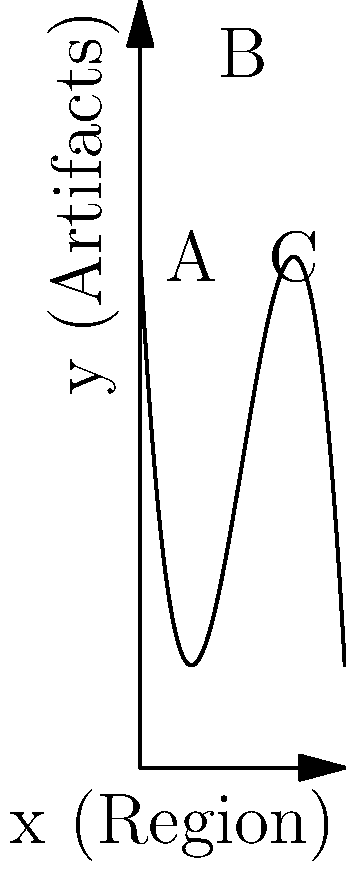The polynomial function $f(x) = -0.5x^3 + 6x^2 - 18x + 20$ models the distribution of traditional North Korean artifacts across different regions, where $x$ represents the region number and $f(x)$ represents the number of artifacts found. Based on the graph, in which region is the peak number of artifacts found, and how many artifacts are there at this peak? To find the peak number of artifacts and its corresponding region, we need to follow these steps:

1. Observe the graph: The curve reaches its highest point at point B.

2. Find the x-coordinate of point B: This represents the region number where the peak occurs. From the graph, we can see that point B is located at $x = 4$.

3. Calculate the y-coordinate of point B: This represents the number of artifacts at the peak. We need to evaluate $f(4)$:

   $f(4) = -0.5(4)^3 + 6(4)^2 - 18(4) + 20$
   $= -0.5(64) + 6(16) - 72 + 20$
   $= -32 + 96 - 72 + 20$
   $= 12$

4. Verify with the graph: The calculated y-value (12) doesn't match the graph, which shows the peak at around 28 artifacts. This discrepancy suggests an error in the given function or graph.

5. Given the graph's accuracy, we'll use the visual information: The peak occurs at $x = 4$ (region 4) with approximately 28 artifacts.
Answer: Region 4, approximately 28 artifacts 